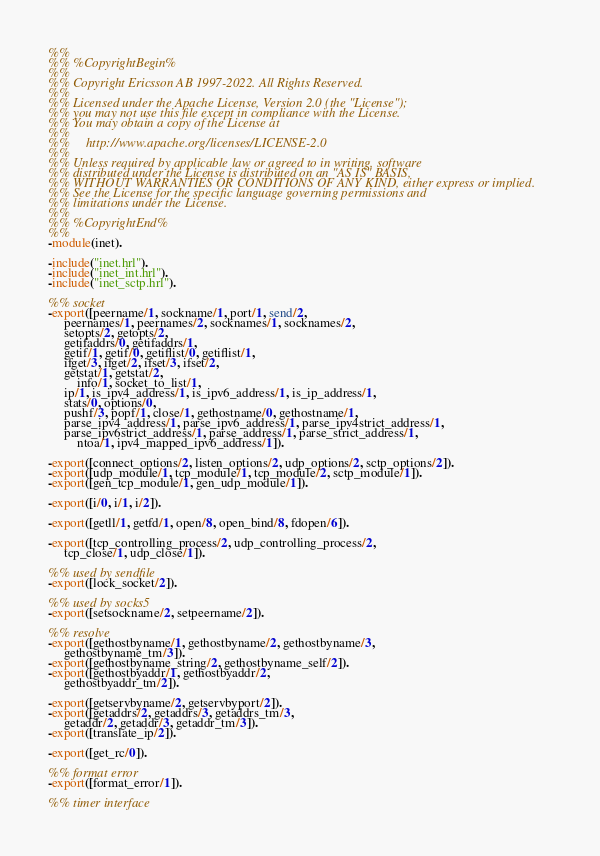Convert code to text. <code><loc_0><loc_0><loc_500><loc_500><_Erlang_>%%
%% %CopyrightBegin%
%%
%% Copyright Ericsson AB 1997-2022. All Rights Reserved.
%%
%% Licensed under the Apache License, Version 2.0 (the "License");
%% you may not use this file except in compliance with the License.
%% You may obtain a copy of the License at
%%
%%     http://www.apache.org/licenses/LICENSE-2.0
%%
%% Unless required by applicable law or agreed to in writing, software
%% distributed under the License is distributed on an "AS IS" BASIS,
%% WITHOUT WARRANTIES OR CONDITIONS OF ANY KIND, either express or implied.
%% See the License for the specific language governing permissions and
%% limitations under the License.
%%
%% %CopyrightEnd%
%%
-module(inet).

-include("inet.hrl").
-include("inet_int.hrl").
-include("inet_sctp.hrl").

%% socket
-export([peername/1, sockname/1, port/1, send/2,
	 peernames/1, peernames/2, socknames/1, socknames/2,
	 setopts/2, getopts/2, 
	 getifaddrs/0, getifaddrs/1,
	 getif/1, getif/0, getiflist/0, getiflist/1,
	 ifget/3, ifget/2, ifset/3, ifset/2,
	 getstat/1, getstat/2,
         info/1, socket_to_list/1,
	 ip/1, is_ipv4_address/1, is_ipv6_address/1, is_ip_address/1,
	 stats/0, options/0, 
	 pushf/3, popf/1, close/1, gethostname/0, gethostname/1, 
	 parse_ipv4_address/1, parse_ipv6_address/1, parse_ipv4strict_address/1,
	 parse_ipv6strict_address/1, parse_address/1, parse_strict_address/1,
         ntoa/1, ipv4_mapped_ipv6_address/1]).

-export([connect_options/2, listen_options/2, udp_options/2, sctp_options/2]).
-export([udp_module/1, tcp_module/1, tcp_module/2, sctp_module/1]).
-export([gen_tcp_module/1, gen_udp_module/1]).

-export([i/0, i/1, i/2]).

-export([getll/1, getfd/1, open/8, open_bind/8, fdopen/6]).

-export([tcp_controlling_process/2, udp_controlling_process/2,
	 tcp_close/1, udp_close/1]).

%% used by sendfile
-export([lock_socket/2]).

%% used by socks5
-export([setsockname/2, setpeername/2]).

%% resolve
-export([gethostbyname/1, gethostbyname/2, gethostbyname/3, 
	 gethostbyname_tm/3]).
-export([gethostbyname_string/2, gethostbyname_self/2]).
-export([gethostbyaddr/1, gethostbyaddr/2, 
	 gethostbyaddr_tm/2]).

-export([getservbyname/2, getservbyport/2]).
-export([getaddrs/2, getaddrs/3, getaddrs_tm/3,
	 getaddr/2, getaddr/3, getaddr_tm/3]).
-export([translate_ip/2]).

-export([get_rc/0]).

%% format error
-export([format_error/1]).

%% timer interface</code> 